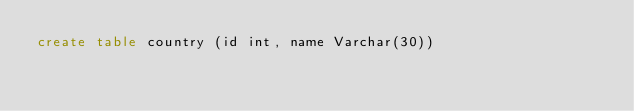<code> <loc_0><loc_0><loc_500><loc_500><_SQL_>create table country (id int, name Varchar(30))</code> 